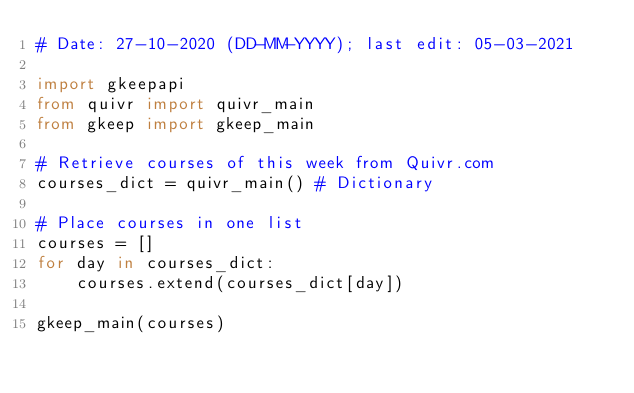<code> <loc_0><loc_0><loc_500><loc_500><_Python_># Date: 27-10-2020 (DD-MM-YYYY); last edit: 05-03-2021

import gkeepapi
from quivr import quivr_main
from gkeep import gkeep_main

# Retrieve courses of this week from Quivr.com
courses_dict = quivr_main() # Dictionary

# Place courses in one list
courses = []
for day in courses_dict:
    courses.extend(courses_dict[day])

gkeep_main(courses)</code> 